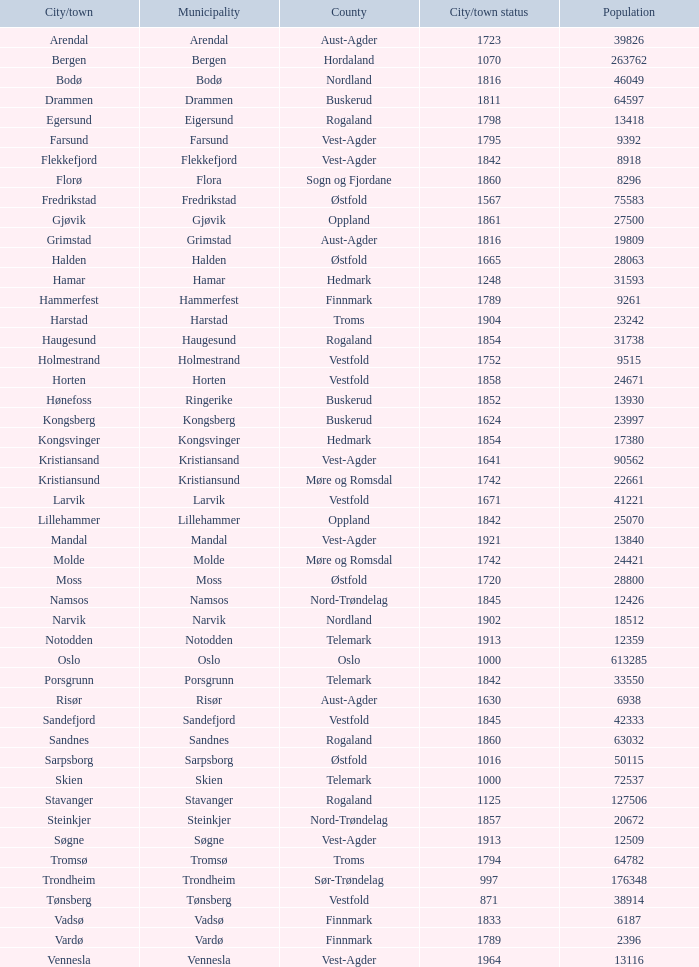Would you be able to parse every entry in this table? {'header': ['City/town', 'Municipality', 'County', 'City/town status', 'Population'], 'rows': [['Arendal', 'Arendal', 'Aust-Agder', '1723', '39826'], ['Bergen', 'Bergen', 'Hordaland', '1070', '263762'], ['Bodø', 'Bodø', 'Nordland', '1816', '46049'], ['Drammen', 'Drammen', 'Buskerud', '1811', '64597'], ['Egersund', 'Eigersund', 'Rogaland', '1798', '13418'], ['Farsund', 'Farsund', 'Vest-Agder', '1795', '9392'], ['Flekkefjord', 'Flekkefjord', 'Vest-Agder', '1842', '8918'], ['Florø', 'Flora', 'Sogn og Fjordane', '1860', '8296'], ['Fredrikstad', 'Fredrikstad', 'Østfold', '1567', '75583'], ['Gjøvik', 'Gjøvik', 'Oppland', '1861', '27500'], ['Grimstad', 'Grimstad', 'Aust-Agder', '1816', '19809'], ['Halden', 'Halden', 'Østfold', '1665', '28063'], ['Hamar', 'Hamar', 'Hedmark', '1248', '31593'], ['Hammerfest', 'Hammerfest', 'Finnmark', '1789', '9261'], ['Harstad', 'Harstad', 'Troms', '1904', '23242'], ['Haugesund', 'Haugesund', 'Rogaland', '1854', '31738'], ['Holmestrand', 'Holmestrand', 'Vestfold', '1752', '9515'], ['Horten', 'Horten', 'Vestfold', '1858', '24671'], ['Hønefoss', 'Ringerike', 'Buskerud', '1852', '13930'], ['Kongsberg', 'Kongsberg', 'Buskerud', '1624', '23997'], ['Kongsvinger', 'Kongsvinger', 'Hedmark', '1854', '17380'], ['Kristiansand', 'Kristiansand', 'Vest-Agder', '1641', '90562'], ['Kristiansund', 'Kristiansund', 'Møre og Romsdal', '1742', '22661'], ['Larvik', 'Larvik', 'Vestfold', '1671', '41221'], ['Lillehammer', 'Lillehammer', 'Oppland', '1842', '25070'], ['Mandal', 'Mandal', 'Vest-Agder', '1921', '13840'], ['Molde', 'Molde', 'Møre og Romsdal', '1742', '24421'], ['Moss', 'Moss', 'Østfold', '1720', '28800'], ['Namsos', 'Namsos', 'Nord-Trøndelag', '1845', '12426'], ['Narvik', 'Narvik', 'Nordland', '1902', '18512'], ['Notodden', 'Notodden', 'Telemark', '1913', '12359'], ['Oslo', 'Oslo', 'Oslo', '1000', '613285'], ['Porsgrunn', 'Porsgrunn', 'Telemark', '1842', '33550'], ['Risør', 'Risør', 'Aust-Agder', '1630', '6938'], ['Sandefjord', 'Sandefjord', 'Vestfold', '1845', '42333'], ['Sandnes', 'Sandnes', 'Rogaland', '1860', '63032'], ['Sarpsborg', 'Sarpsborg', 'Østfold', '1016', '50115'], ['Skien', 'Skien', 'Telemark', '1000', '72537'], ['Stavanger', 'Stavanger', 'Rogaland', '1125', '127506'], ['Steinkjer', 'Steinkjer', 'Nord-Trøndelag', '1857', '20672'], ['Søgne', 'Søgne', 'Vest-Agder', '1913', '12509'], ['Tromsø', 'Tromsø', 'Troms', '1794', '64782'], ['Trondheim', 'Trondheim', 'Sør-Trøndelag', '997', '176348'], ['Tønsberg', 'Tønsberg', 'Vestfold', '871', '38914'], ['Vadsø', 'Vadsø', 'Finnmark', '1833', '6187'], ['Vardø', 'Vardø', 'Finnmark', '1789', '2396'], ['Vennesla', 'Vennesla', 'Vest-Agder', '1964', '13116']]} 0? Hammerfest. 